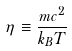Convert formula to latex. <formula><loc_0><loc_0><loc_500><loc_500>\eta \equiv \frac { m c ^ { 2 } } { k _ { B } T }</formula> 